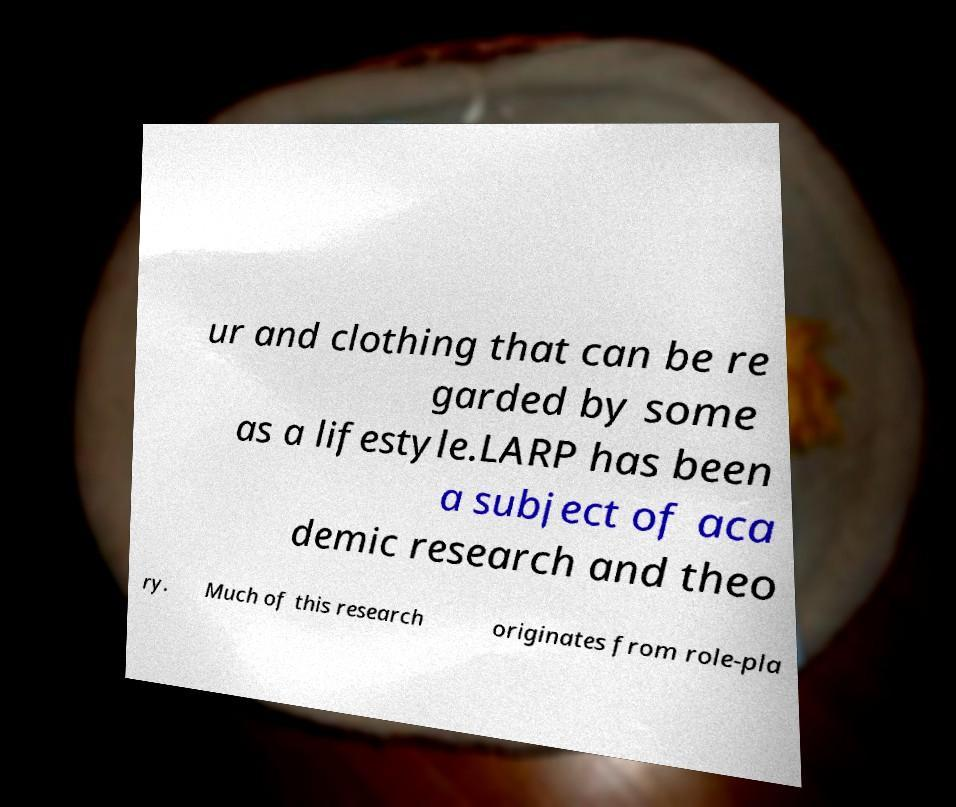There's text embedded in this image that I need extracted. Can you transcribe it verbatim? ur and clothing that can be re garded by some as a lifestyle.LARP has been a subject of aca demic research and theo ry. Much of this research originates from role-pla 